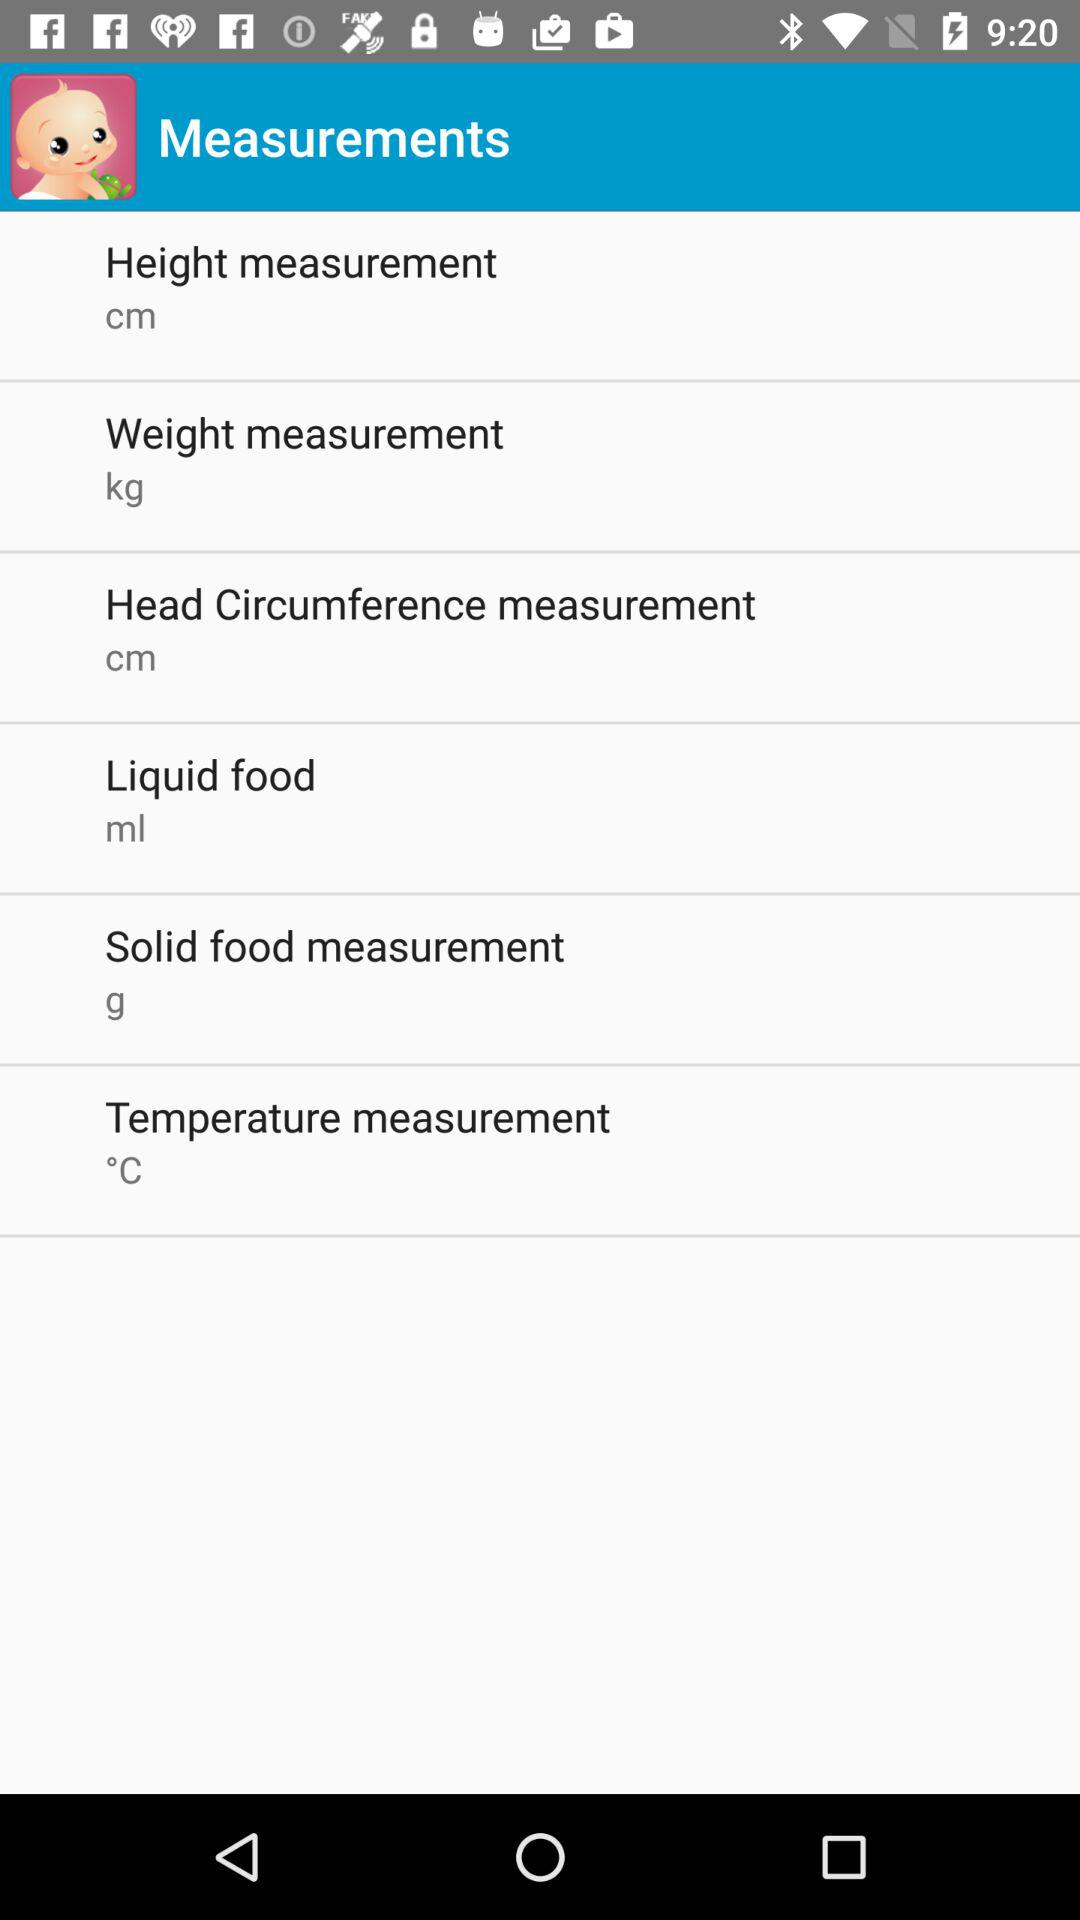Can Fahrenheit be the unit of temperature measurement?
When the provided information is insufficient, respond with <no answer>. <no answer> 